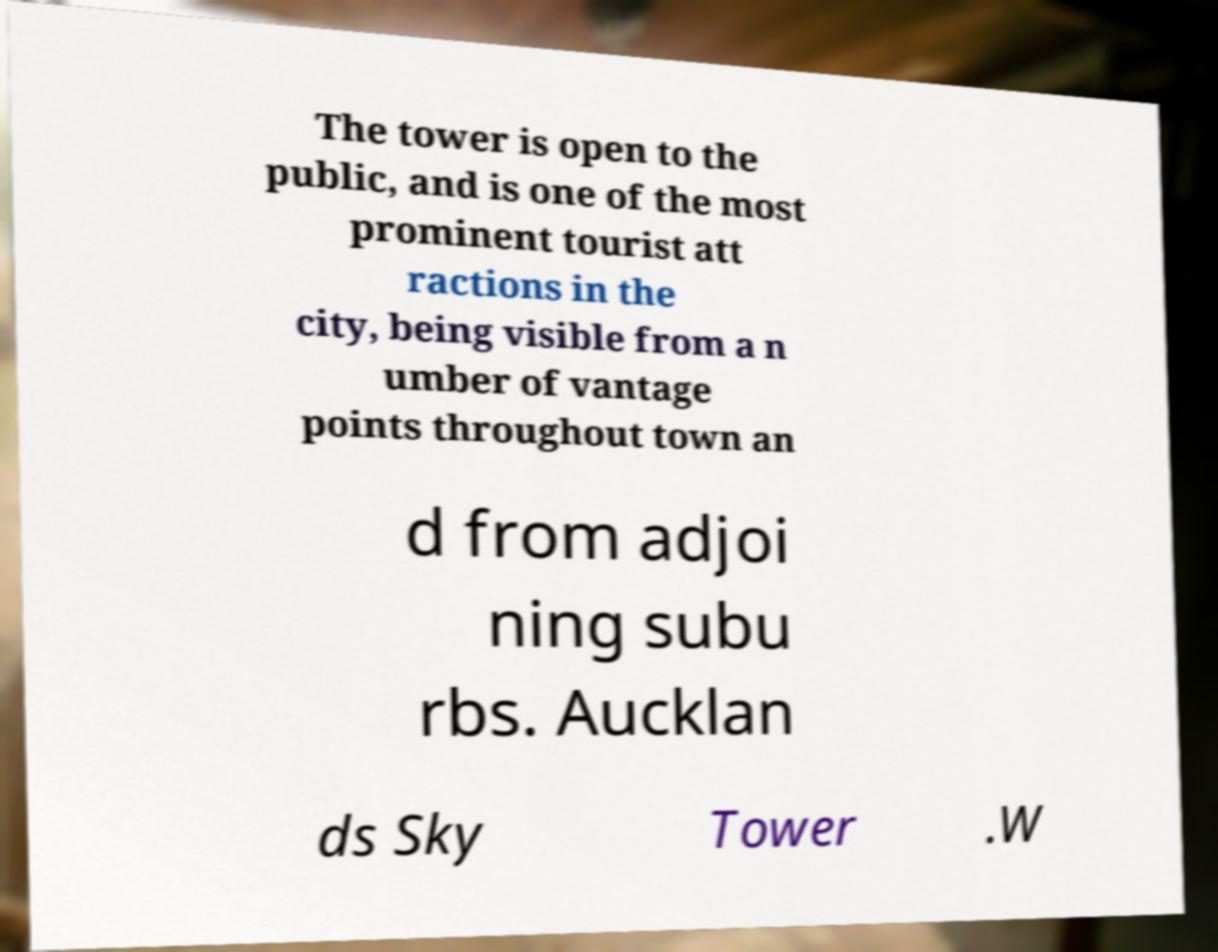There's text embedded in this image that I need extracted. Can you transcribe it verbatim? The tower is open to the public, and is one of the most prominent tourist att ractions in the city, being visible from a n umber of vantage points throughout town an d from adjoi ning subu rbs. Aucklan ds Sky Tower .W 